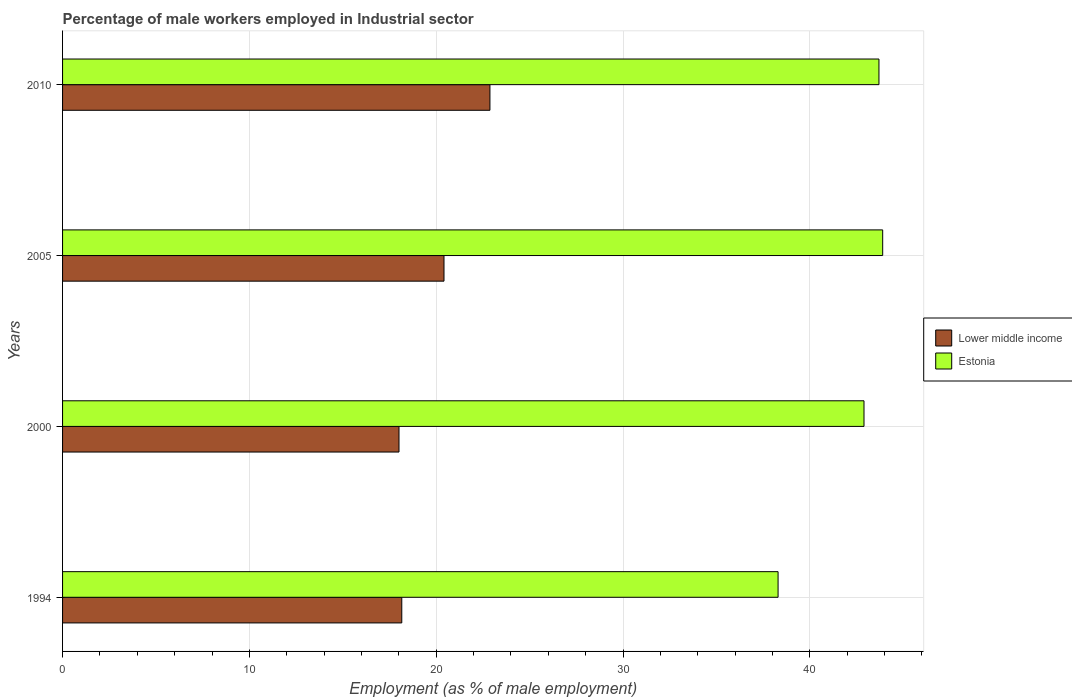How many different coloured bars are there?
Your answer should be very brief. 2. Are the number of bars on each tick of the Y-axis equal?
Your response must be concise. Yes. What is the percentage of male workers employed in Industrial sector in Estonia in 2010?
Offer a very short reply. 43.7. Across all years, what is the maximum percentage of male workers employed in Industrial sector in Estonia?
Provide a succinct answer. 43.9. Across all years, what is the minimum percentage of male workers employed in Industrial sector in Estonia?
Keep it short and to the point. 38.3. In which year was the percentage of male workers employed in Industrial sector in Estonia minimum?
Offer a very short reply. 1994. What is the total percentage of male workers employed in Industrial sector in Estonia in the graph?
Your answer should be compact. 168.8. What is the difference between the percentage of male workers employed in Industrial sector in Lower middle income in 1994 and that in 2000?
Offer a very short reply. 0.15. What is the difference between the percentage of male workers employed in Industrial sector in Lower middle income in 2010 and the percentage of male workers employed in Industrial sector in Estonia in 1994?
Provide a short and direct response. -15.42. What is the average percentage of male workers employed in Industrial sector in Lower middle income per year?
Your response must be concise. 19.86. In the year 2005, what is the difference between the percentage of male workers employed in Industrial sector in Lower middle income and percentage of male workers employed in Industrial sector in Estonia?
Your response must be concise. -23.48. What is the ratio of the percentage of male workers employed in Industrial sector in Lower middle income in 1994 to that in 2005?
Give a very brief answer. 0.89. Is the difference between the percentage of male workers employed in Industrial sector in Lower middle income in 2000 and 2010 greater than the difference between the percentage of male workers employed in Industrial sector in Estonia in 2000 and 2010?
Give a very brief answer. No. What is the difference between the highest and the second highest percentage of male workers employed in Industrial sector in Estonia?
Offer a terse response. 0.2. What is the difference between the highest and the lowest percentage of male workers employed in Industrial sector in Estonia?
Your answer should be very brief. 5.6. What does the 2nd bar from the top in 2005 represents?
Your answer should be compact. Lower middle income. What does the 1st bar from the bottom in 2000 represents?
Make the answer very short. Lower middle income. How many bars are there?
Ensure brevity in your answer.  8. What is the difference between two consecutive major ticks on the X-axis?
Your response must be concise. 10. Does the graph contain grids?
Ensure brevity in your answer.  Yes. Where does the legend appear in the graph?
Offer a very short reply. Center right. What is the title of the graph?
Offer a terse response. Percentage of male workers employed in Industrial sector. What is the label or title of the X-axis?
Keep it short and to the point. Employment (as % of male employment). What is the label or title of the Y-axis?
Give a very brief answer. Years. What is the Employment (as % of male employment) in Lower middle income in 1994?
Ensure brevity in your answer.  18.16. What is the Employment (as % of male employment) of Estonia in 1994?
Your response must be concise. 38.3. What is the Employment (as % of male employment) in Lower middle income in 2000?
Give a very brief answer. 18.01. What is the Employment (as % of male employment) in Estonia in 2000?
Offer a terse response. 42.9. What is the Employment (as % of male employment) of Lower middle income in 2005?
Keep it short and to the point. 20.42. What is the Employment (as % of male employment) of Estonia in 2005?
Offer a terse response. 43.9. What is the Employment (as % of male employment) in Lower middle income in 2010?
Give a very brief answer. 22.88. What is the Employment (as % of male employment) in Estonia in 2010?
Ensure brevity in your answer.  43.7. Across all years, what is the maximum Employment (as % of male employment) of Lower middle income?
Offer a very short reply. 22.88. Across all years, what is the maximum Employment (as % of male employment) of Estonia?
Provide a succinct answer. 43.9. Across all years, what is the minimum Employment (as % of male employment) of Lower middle income?
Offer a terse response. 18.01. Across all years, what is the minimum Employment (as % of male employment) in Estonia?
Offer a terse response. 38.3. What is the total Employment (as % of male employment) in Lower middle income in the graph?
Make the answer very short. 79.46. What is the total Employment (as % of male employment) of Estonia in the graph?
Offer a very short reply. 168.8. What is the difference between the Employment (as % of male employment) of Lower middle income in 1994 and that in 2000?
Keep it short and to the point. 0.15. What is the difference between the Employment (as % of male employment) of Estonia in 1994 and that in 2000?
Give a very brief answer. -4.6. What is the difference between the Employment (as % of male employment) of Lower middle income in 1994 and that in 2005?
Ensure brevity in your answer.  -2.26. What is the difference between the Employment (as % of male employment) of Estonia in 1994 and that in 2005?
Offer a very short reply. -5.6. What is the difference between the Employment (as % of male employment) of Lower middle income in 1994 and that in 2010?
Ensure brevity in your answer.  -4.72. What is the difference between the Employment (as % of male employment) of Estonia in 1994 and that in 2010?
Provide a succinct answer. -5.4. What is the difference between the Employment (as % of male employment) of Lower middle income in 2000 and that in 2005?
Ensure brevity in your answer.  -2.41. What is the difference between the Employment (as % of male employment) of Estonia in 2000 and that in 2005?
Keep it short and to the point. -1. What is the difference between the Employment (as % of male employment) of Lower middle income in 2000 and that in 2010?
Your response must be concise. -4.87. What is the difference between the Employment (as % of male employment) in Lower middle income in 2005 and that in 2010?
Provide a succinct answer. -2.46. What is the difference between the Employment (as % of male employment) in Estonia in 2005 and that in 2010?
Offer a terse response. 0.2. What is the difference between the Employment (as % of male employment) of Lower middle income in 1994 and the Employment (as % of male employment) of Estonia in 2000?
Your response must be concise. -24.74. What is the difference between the Employment (as % of male employment) in Lower middle income in 1994 and the Employment (as % of male employment) in Estonia in 2005?
Give a very brief answer. -25.74. What is the difference between the Employment (as % of male employment) of Lower middle income in 1994 and the Employment (as % of male employment) of Estonia in 2010?
Make the answer very short. -25.54. What is the difference between the Employment (as % of male employment) in Lower middle income in 2000 and the Employment (as % of male employment) in Estonia in 2005?
Your response must be concise. -25.89. What is the difference between the Employment (as % of male employment) of Lower middle income in 2000 and the Employment (as % of male employment) of Estonia in 2010?
Your answer should be compact. -25.69. What is the difference between the Employment (as % of male employment) of Lower middle income in 2005 and the Employment (as % of male employment) of Estonia in 2010?
Give a very brief answer. -23.28. What is the average Employment (as % of male employment) of Lower middle income per year?
Ensure brevity in your answer.  19.86. What is the average Employment (as % of male employment) in Estonia per year?
Provide a short and direct response. 42.2. In the year 1994, what is the difference between the Employment (as % of male employment) in Lower middle income and Employment (as % of male employment) in Estonia?
Provide a succinct answer. -20.14. In the year 2000, what is the difference between the Employment (as % of male employment) of Lower middle income and Employment (as % of male employment) of Estonia?
Provide a short and direct response. -24.89. In the year 2005, what is the difference between the Employment (as % of male employment) in Lower middle income and Employment (as % of male employment) in Estonia?
Give a very brief answer. -23.48. In the year 2010, what is the difference between the Employment (as % of male employment) in Lower middle income and Employment (as % of male employment) in Estonia?
Your response must be concise. -20.82. What is the ratio of the Employment (as % of male employment) in Lower middle income in 1994 to that in 2000?
Your answer should be compact. 1.01. What is the ratio of the Employment (as % of male employment) of Estonia in 1994 to that in 2000?
Make the answer very short. 0.89. What is the ratio of the Employment (as % of male employment) of Lower middle income in 1994 to that in 2005?
Ensure brevity in your answer.  0.89. What is the ratio of the Employment (as % of male employment) in Estonia in 1994 to that in 2005?
Provide a short and direct response. 0.87. What is the ratio of the Employment (as % of male employment) of Lower middle income in 1994 to that in 2010?
Offer a very short reply. 0.79. What is the ratio of the Employment (as % of male employment) of Estonia in 1994 to that in 2010?
Ensure brevity in your answer.  0.88. What is the ratio of the Employment (as % of male employment) in Lower middle income in 2000 to that in 2005?
Keep it short and to the point. 0.88. What is the ratio of the Employment (as % of male employment) in Estonia in 2000 to that in 2005?
Offer a very short reply. 0.98. What is the ratio of the Employment (as % of male employment) of Lower middle income in 2000 to that in 2010?
Keep it short and to the point. 0.79. What is the ratio of the Employment (as % of male employment) in Estonia in 2000 to that in 2010?
Offer a very short reply. 0.98. What is the ratio of the Employment (as % of male employment) in Lower middle income in 2005 to that in 2010?
Your answer should be compact. 0.89. What is the ratio of the Employment (as % of male employment) in Estonia in 2005 to that in 2010?
Your response must be concise. 1. What is the difference between the highest and the second highest Employment (as % of male employment) of Lower middle income?
Your answer should be very brief. 2.46. What is the difference between the highest and the second highest Employment (as % of male employment) in Estonia?
Provide a short and direct response. 0.2. What is the difference between the highest and the lowest Employment (as % of male employment) of Lower middle income?
Give a very brief answer. 4.87. What is the difference between the highest and the lowest Employment (as % of male employment) in Estonia?
Your answer should be compact. 5.6. 